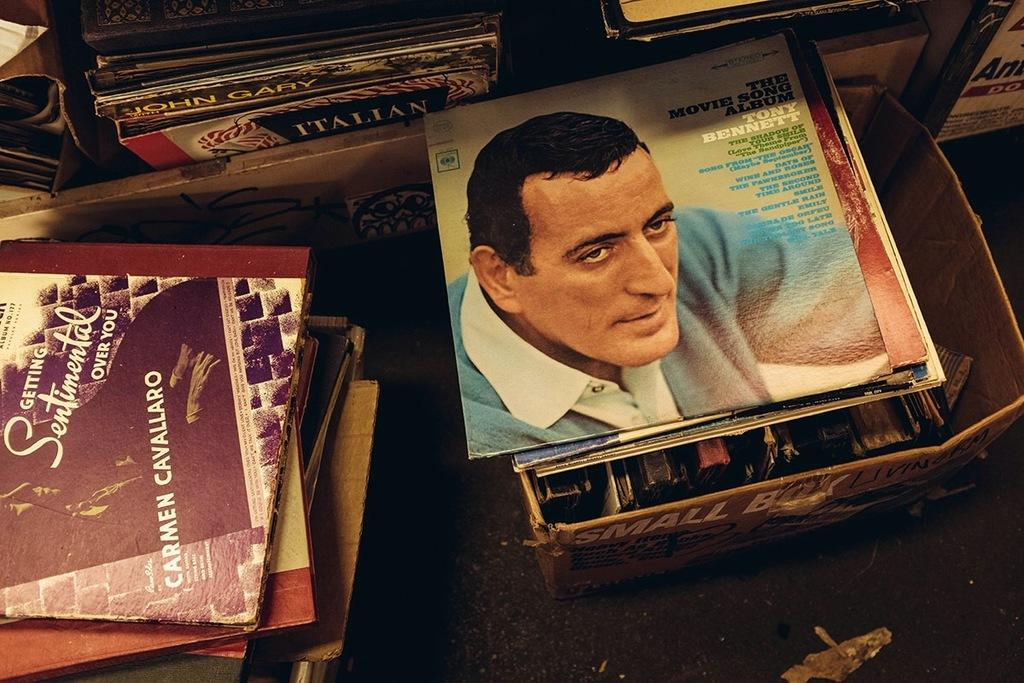<image>
Offer a succinct explanation of the picture presented. Album covers including The Movie Song Album by Tony Bennett. 